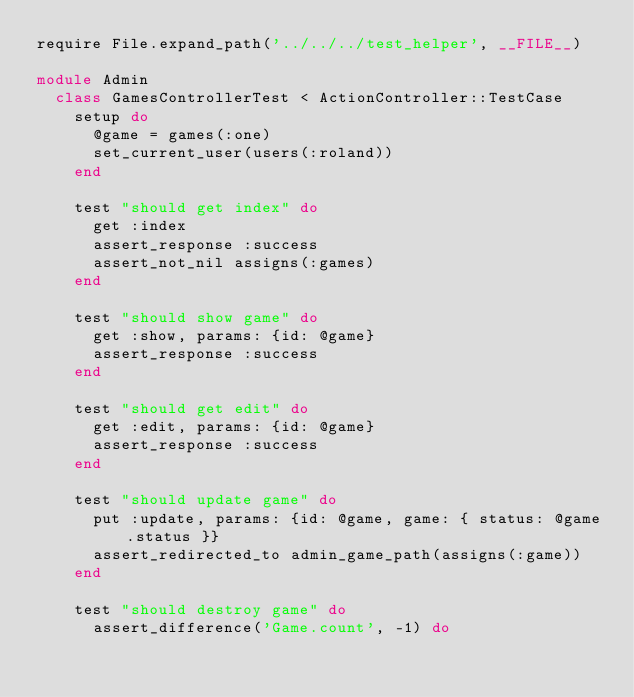Convert code to text. <code><loc_0><loc_0><loc_500><loc_500><_Ruby_>require File.expand_path('../../../test_helper', __FILE__)

module Admin
  class GamesControllerTest < ActionController::TestCase
    setup do
      @game = games(:one)
      set_current_user(users(:roland))
    end

    test "should get index" do
      get :index
      assert_response :success
      assert_not_nil assigns(:games)
    end

    test "should show game" do
      get :show, params: {id: @game}
      assert_response :success
    end

    test "should get edit" do
      get :edit, params: {id: @game}
      assert_response :success
    end

    test "should update game" do
      put :update, params: {id: @game, game: { status: @game.status }}
      assert_redirected_to admin_game_path(assigns(:game))
    end

    test "should destroy game" do
      assert_difference('Game.count', -1) do</code> 